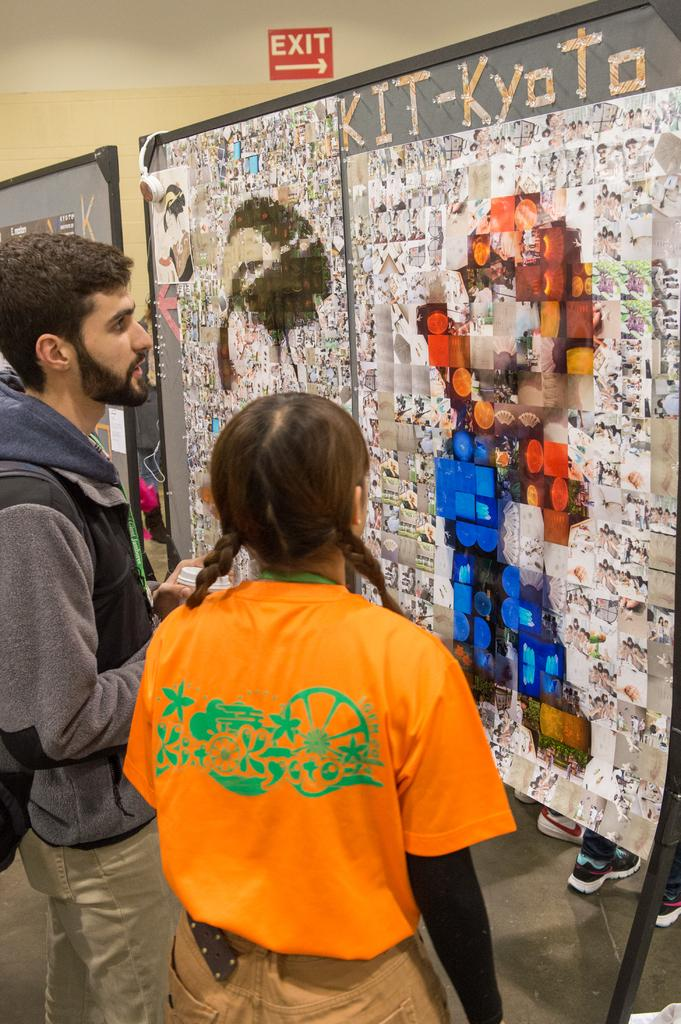How many people are present in the image? There are two people in the image. What can be seen written on a wall in the image? There is text written on a wall in the image. How many fans are visible in the image? There are no fans visible in the image. What type of chickens can be seen in the image? There are no chickens present in the image. 